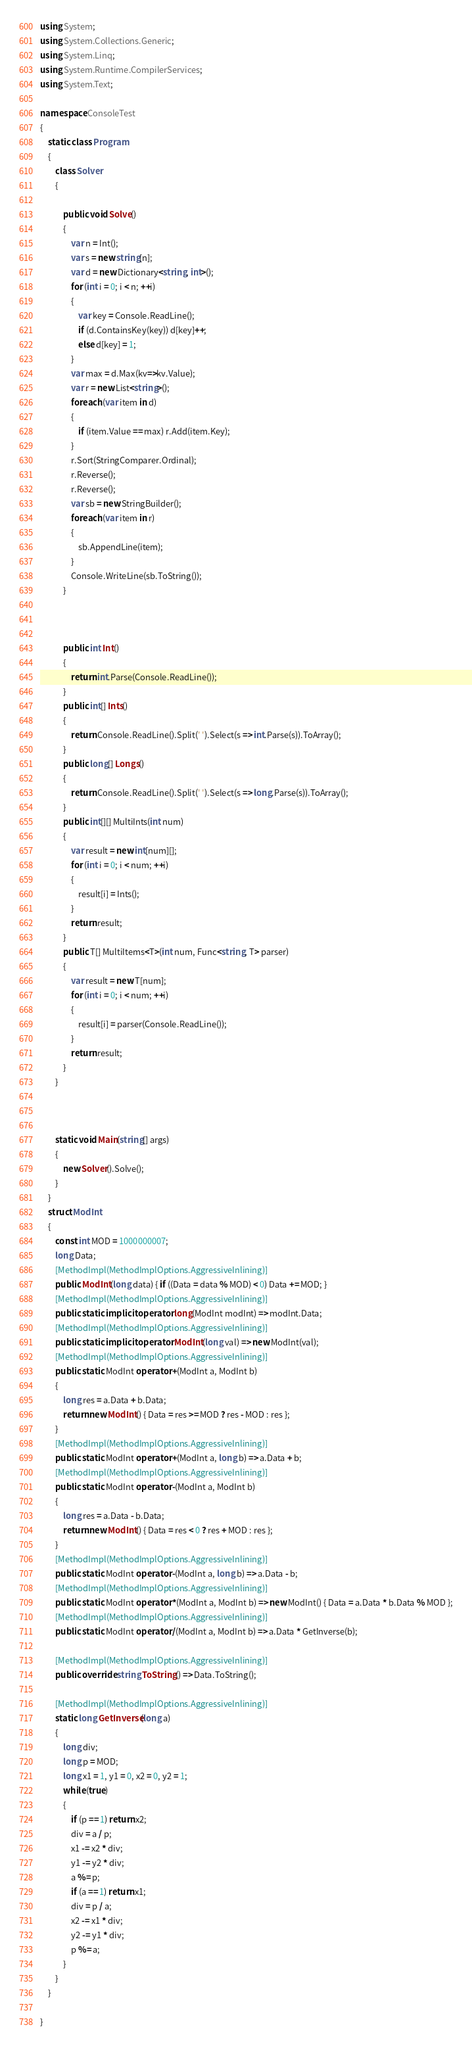Convert code to text. <code><loc_0><loc_0><loc_500><loc_500><_C#_>using System;
using System.Collections.Generic;
using System.Linq;
using System.Runtime.CompilerServices;
using System.Text;

namespace ConsoleTest
{
    static class Program
    {
        class Solver
        {

            public void Solve()
            {
                var n = Int();
                var s = new string[n];
                var d = new Dictionary<string, int>();
                for (int i = 0; i < n; ++i)
                {
                    var key = Console.ReadLine();
                    if (d.ContainsKey(key)) d[key]++;
                    else d[key] = 1;
                }
                var max = d.Max(kv=>kv.Value);
                var r = new List<string>();
                foreach (var item in d)
                {
                    if (item.Value == max) r.Add(item.Key);
                }
                r.Sort(StringComparer.Ordinal);
                r.Reverse();
                r.Reverse();
                var sb = new StringBuilder();
                foreach (var item in r)
                {
                    sb.AppendLine(item);
                }
                Console.WriteLine(sb.ToString());
            }



            public int Int()
            {
                return int.Parse(Console.ReadLine());
            }
            public int[] Ints()
            {
                return Console.ReadLine().Split(' ').Select(s => int.Parse(s)).ToArray();
            }
            public long[] Longs()
            {
                return Console.ReadLine().Split(' ').Select(s => long.Parse(s)).ToArray();
            }
            public int[][] MultiInts(int num)
            {
                var result = new int[num][];
                for (int i = 0; i < num; ++i)
                {
                    result[i] = Ints();
                }
                return result;
            }
            public T[] MultiItems<T>(int num, Func<string, T> parser)
            {
                var result = new T[num];
                for (int i = 0; i < num; ++i)
                {
                    result[i] = parser(Console.ReadLine());
                }
                return result;
            }
        }
        
  

        static void Main(string[] args)
        {
            new Solver().Solve();
        }
    }
    struct ModInt
    {
        const int MOD = 1000000007;
        long Data;
        [MethodImpl(MethodImplOptions.AggressiveInlining)]
        public ModInt(long data) { if ((Data = data % MOD) < 0) Data += MOD; }
        [MethodImpl(MethodImplOptions.AggressiveInlining)]
        public static implicit operator long(ModInt modInt) => modInt.Data;
        [MethodImpl(MethodImplOptions.AggressiveInlining)]
        public static implicit operator ModInt(long val) => new ModInt(val);
        [MethodImpl(MethodImplOptions.AggressiveInlining)]
        public static ModInt operator +(ModInt a, ModInt b)
        {
            long res = a.Data + b.Data;
            return new ModInt() { Data = res >= MOD ? res - MOD : res };
        }
        [MethodImpl(MethodImplOptions.AggressiveInlining)]
        public static ModInt operator +(ModInt a, long b) => a.Data + b;
        [MethodImpl(MethodImplOptions.AggressiveInlining)]
        public static ModInt operator -(ModInt a, ModInt b)
        {
            long res = a.Data - b.Data;
            return new ModInt() { Data = res < 0 ? res + MOD : res };
        }
        [MethodImpl(MethodImplOptions.AggressiveInlining)]
        public static ModInt operator -(ModInt a, long b) => a.Data - b;
        [MethodImpl(MethodImplOptions.AggressiveInlining)]
        public static ModInt operator *(ModInt a, ModInt b) => new ModInt() { Data = a.Data * b.Data % MOD };
        [MethodImpl(MethodImplOptions.AggressiveInlining)]
        public static ModInt operator /(ModInt a, ModInt b) => a.Data * GetInverse(b);

        [MethodImpl(MethodImplOptions.AggressiveInlining)]
        public override string ToString() => Data.ToString();

        [MethodImpl(MethodImplOptions.AggressiveInlining)]
        static long GetInverse(long a)
        {
            long div;
            long p = MOD;
            long x1 = 1, y1 = 0, x2 = 0, y2 = 1;
            while (true)
            {
                if (p == 1) return x2;
                div = a / p;
                x1 -= x2 * div;
                y1 -= y2 * div;
                a %= p;
                if (a == 1) return x1;
                div = p / a;
                x2 -= x1 * div;
                y2 -= y1 * div;
                p %= a;
            }
        }
    }

}
</code> 